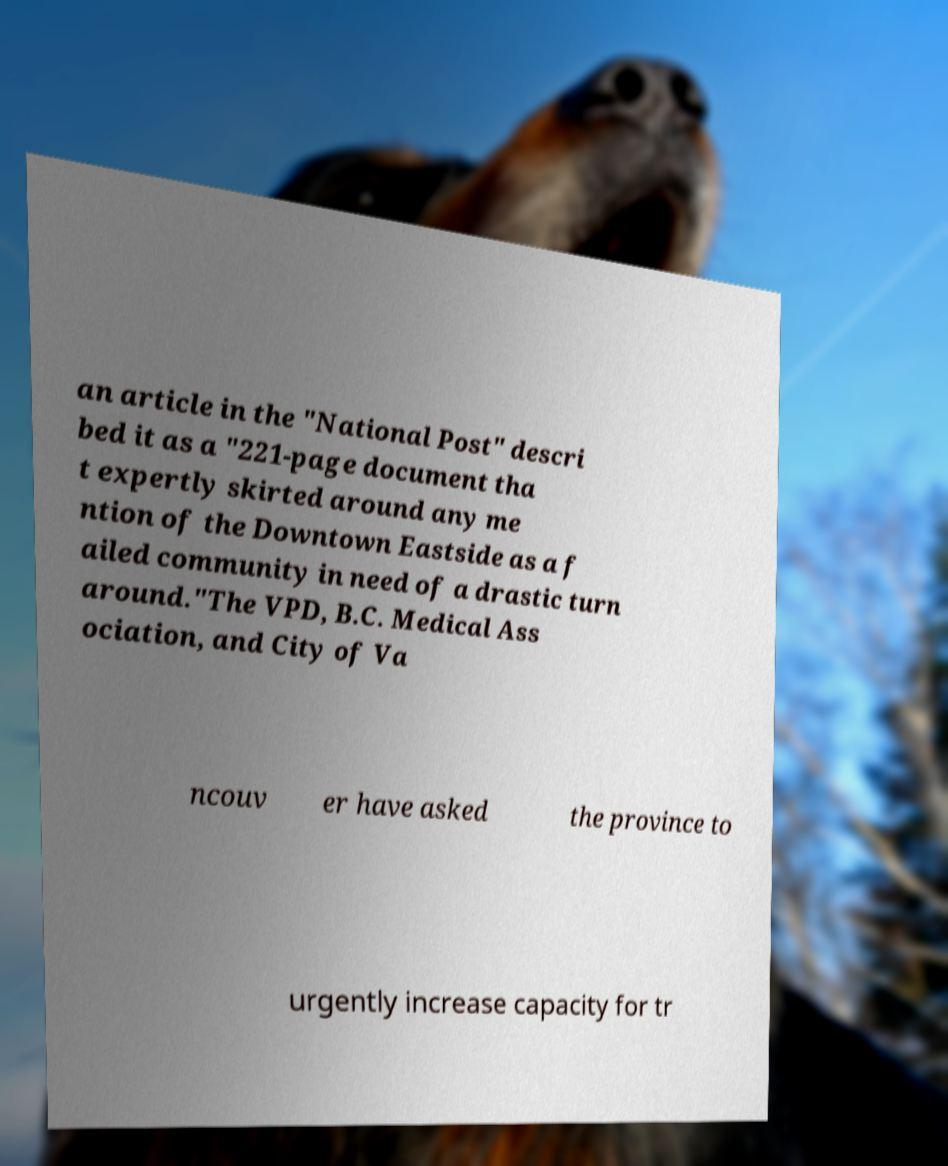Please read and relay the text visible in this image. What does it say? an article in the "National Post" descri bed it as a "221-page document tha t expertly skirted around any me ntion of the Downtown Eastside as a f ailed community in need of a drastic turn around."The VPD, B.C. Medical Ass ociation, and City of Va ncouv er have asked the province to urgently increase capacity for tr 